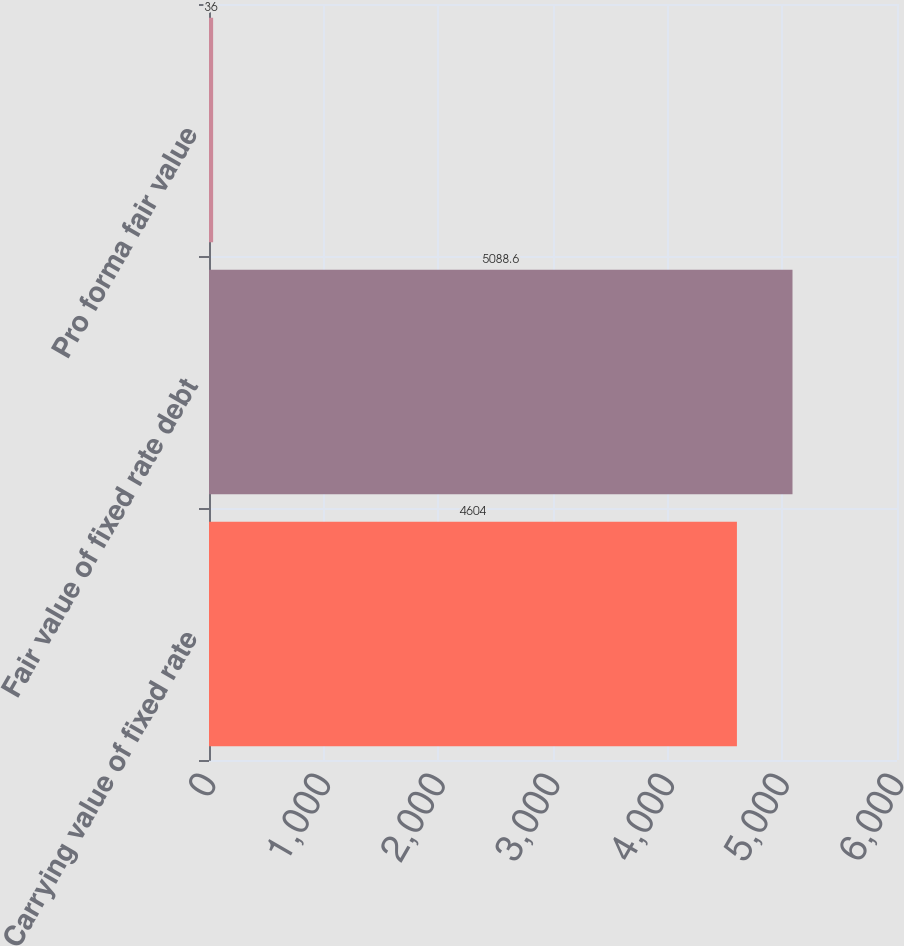Convert chart. <chart><loc_0><loc_0><loc_500><loc_500><bar_chart><fcel>Carrying value of fixed rate<fcel>Fair value of fixed rate debt<fcel>Pro forma fair value<nl><fcel>4604<fcel>5088.6<fcel>36<nl></chart> 